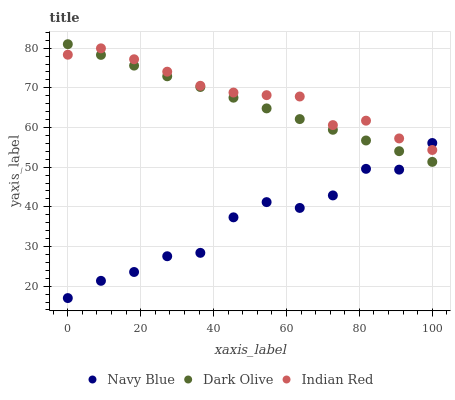Does Navy Blue have the minimum area under the curve?
Answer yes or no. Yes. Does Indian Red have the maximum area under the curve?
Answer yes or no. Yes. Does Dark Olive have the minimum area under the curve?
Answer yes or no. No. Does Dark Olive have the maximum area under the curve?
Answer yes or no. No. Is Dark Olive the smoothest?
Answer yes or no. Yes. Is Navy Blue the roughest?
Answer yes or no. Yes. Is Indian Red the smoothest?
Answer yes or no. No. Is Indian Red the roughest?
Answer yes or no. No. Does Navy Blue have the lowest value?
Answer yes or no. Yes. Does Dark Olive have the lowest value?
Answer yes or no. No. Does Dark Olive have the highest value?
Answer yes or no. Yes. Does Indian Red have the highest value?
Answer yes or no. No. Does Dark Olive intersect Navy Blue?
Answer yes or no. Yes. Is Dark Olive less than Navy Blue?
Answer yes or no. No. Is Dark Olive greater than Navy Blue?
Answer yes or no. No. 